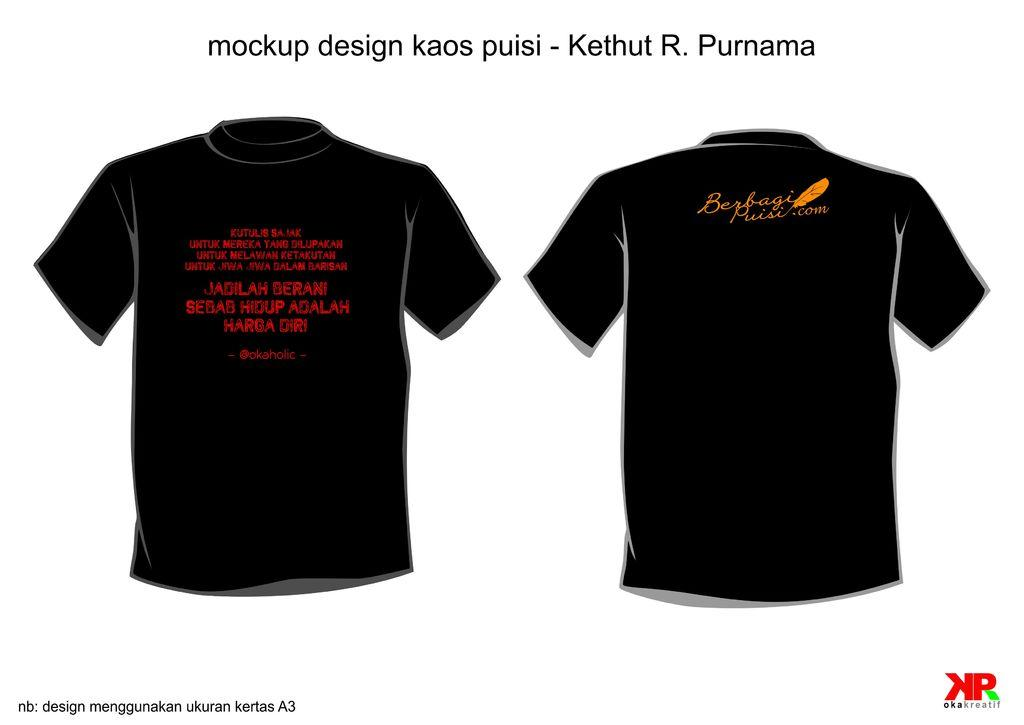What can be observed about the image's appearance? The image appears to be edited. What items are visible in the image? There are two T-shirts with letters on them. What might be the purpose of the letters on the T-shirts? The letters on the T-shirts may be watermarks. What color is the background of the image? The background of the image is white in color. How many kittens are sitting on the owner's lap in the image? There are no kittens or owners present in the image; it features two T-shirts with letters. What type of joke is being told in the image? There is no joke being told in the image; it features two T-shirts with letters. 